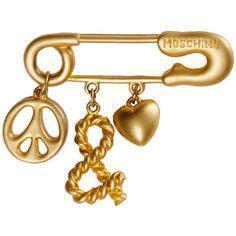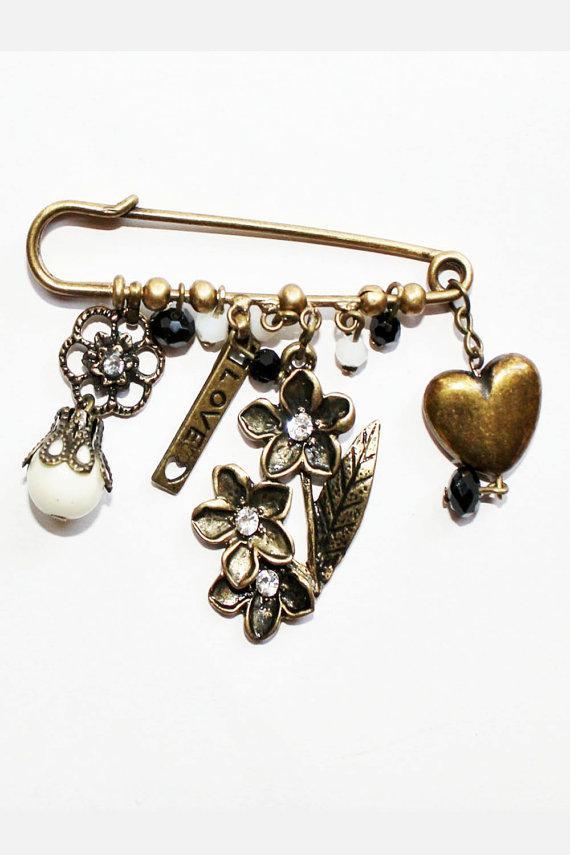The first image is the image on the left, the second image is the image on the right. For the images displayed, is the sentence "The pin on the left is strung with six beads, and the pin on the right features gold letter shapes." factually correct? Answer yes or no. No. The first image is the image on the left, the second image is the image on the right. Examine the images to the left and right. Is the description "There is a heart charm to the right of some other charms." accurate? Answer yes or no. Yes. The first image is the image on the left, the second image is the image on the right. Analyze the images presented: Is the assertion "there is a pin with at least one charm being a key" valid? Answer yes or no. No. The first image is the image on the left, the second image is the image on the right. Examine the images to the left and right. Is the description "A gold safety pin is strung with a row of six black beads and suspends a tassel made of chains." accurate? Answer yes or no. No. 